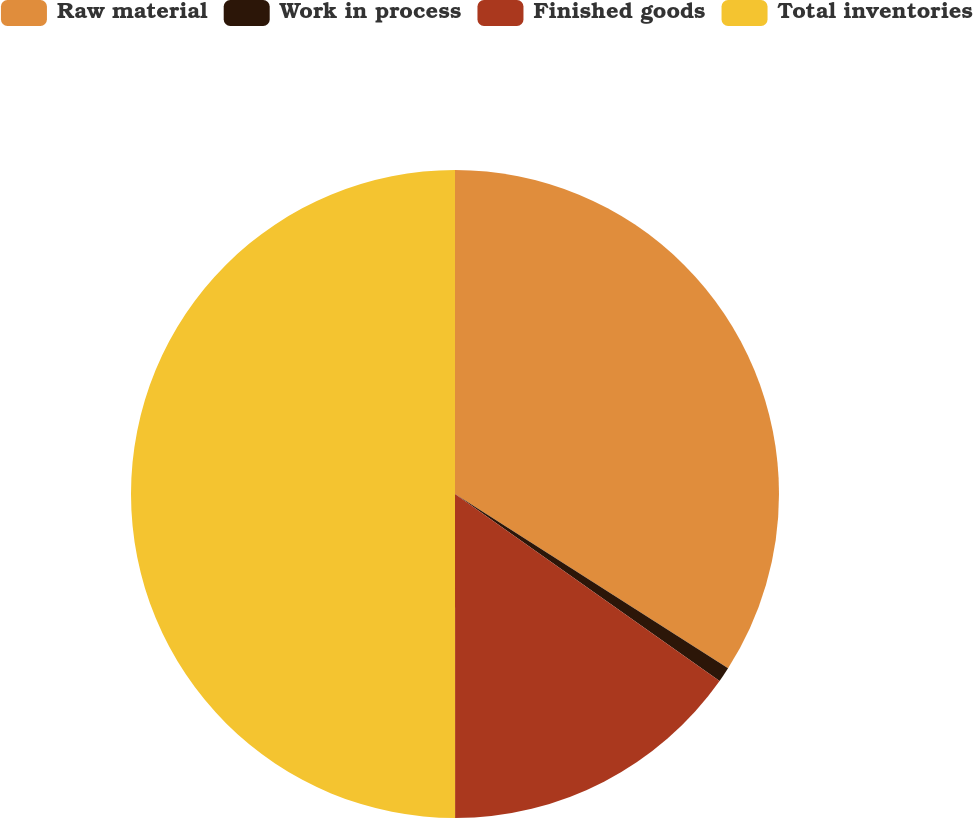Convert chart to OTSL. <chart><loc_0><loc_0><loc_500><loc_500><pie_chart><fcel>Raw material<fcel>Work in process<fcel>Finished goods<fcel>Total inventories<nl><fcel>34.04%<fcel>0.75%<fcel>15.2%<fcel>50.0%<nl></chart> 